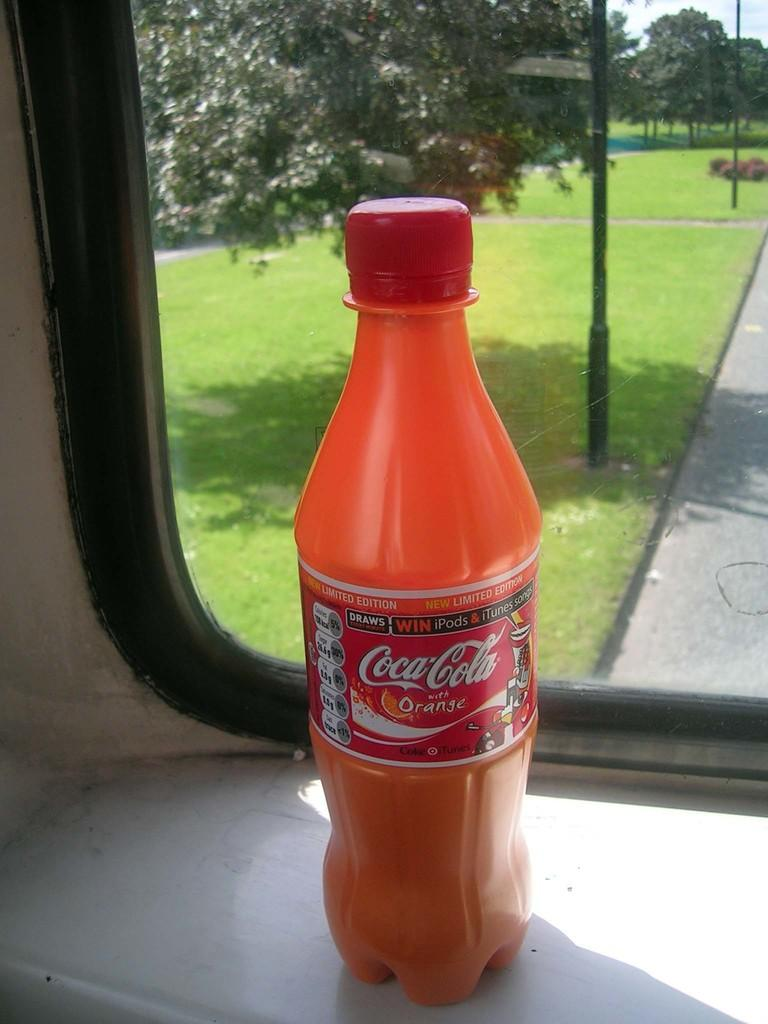Provide a one-sentence caption for the provided image. A bottle of Coca-Cola Orange in front of a window overlooking a grassy park. 